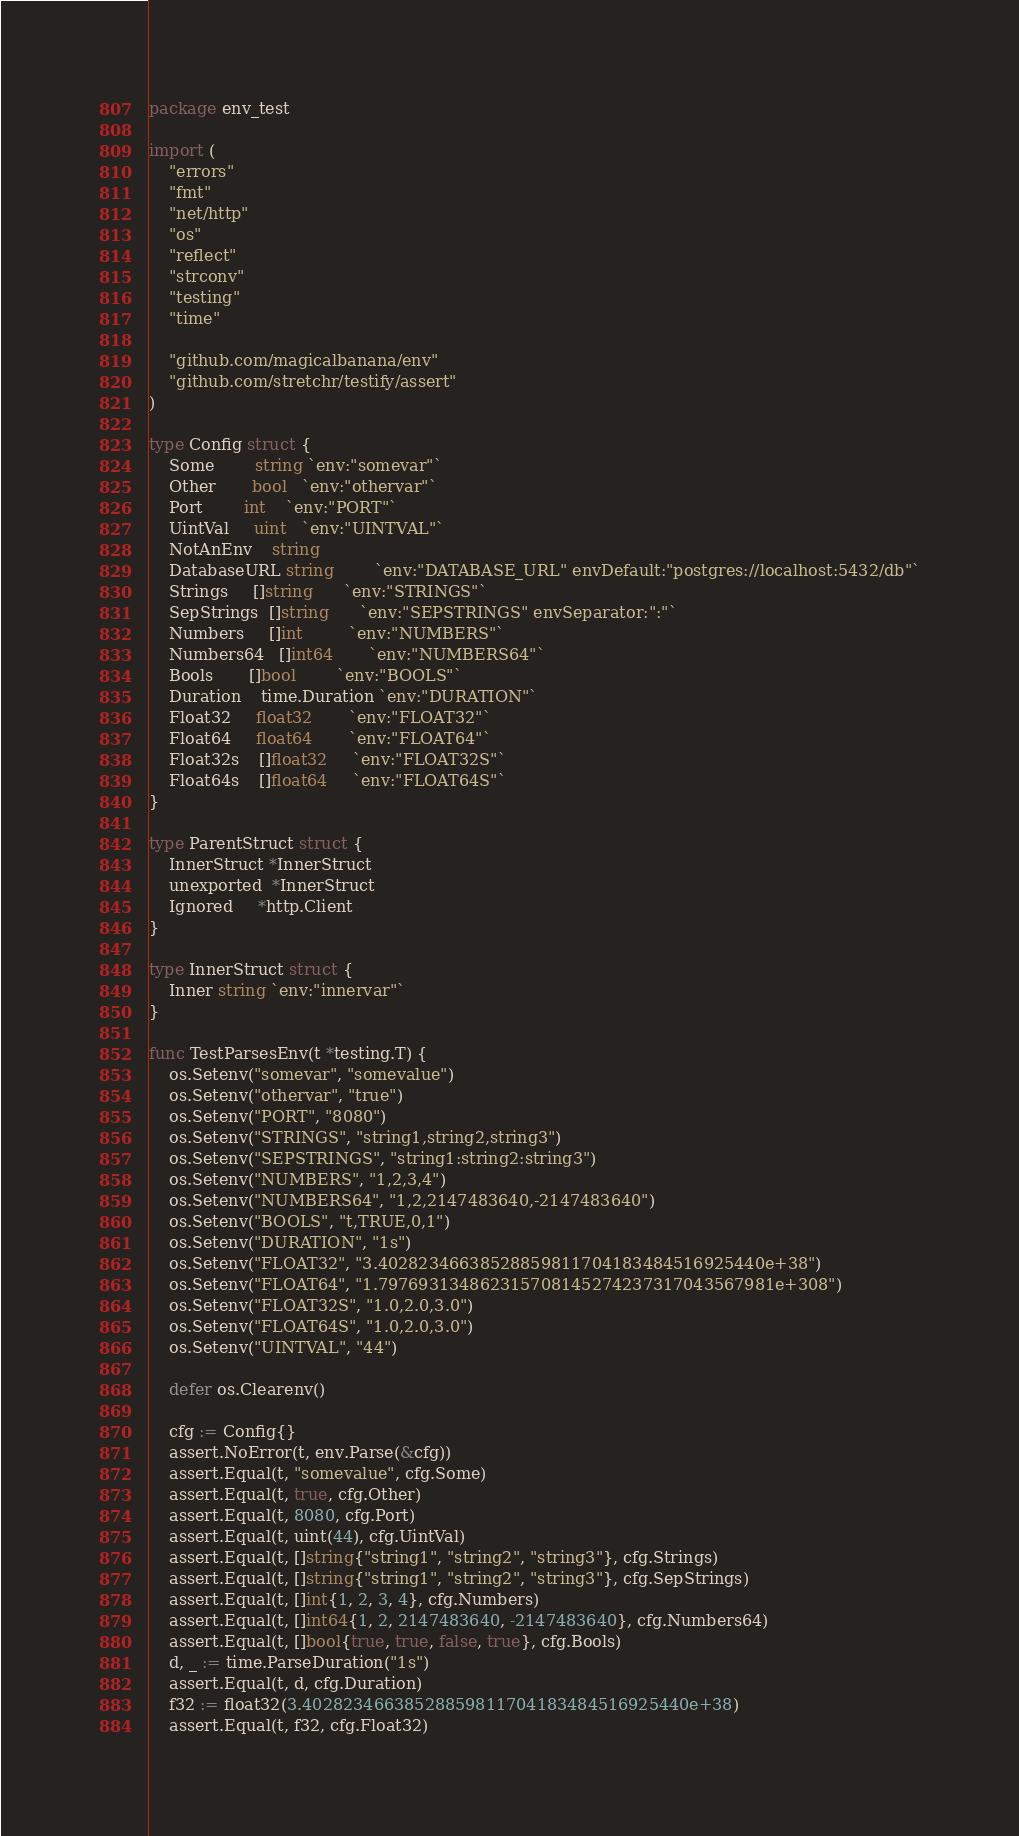<code> <loc_0><loc_0><loc_500><loc_500><_Go_>package env_test

import (
	"errors"
	"fmt"
	"net/http"
	"os"
	"reflect"
	"strconv"
	"testing"
	"time"

	"github.com/magicalbanana/env"
	"github.com/stretchr/testify/assert"
)

type Config struct {
	Some        string `env:"somevar"`
	Other       bool   `env:"othervar"`
	Port        int    `env:"PORT"`
	UintVal     uint   `env:"UINTVAL"`
	NotAnEnv    string
	DatabaseURL string        `env:"DATABASE_URL" envDefault:"postgres://localhost:5432/db"`
	Strings     []string      `env:"STRINGS"`
	SepStrings  []string      `env:"SEPSTRINGS" envSeparator:":"`
	Numbers     []int         `env:"NUMBERS"`
	Numbers64   []int64       `env:"NUMBERS64"`
	Bools       []bool        `env:"BOOLS"`
	Duration    time.Duration `env:"DURATION"`
	Float32     float32       `env:"FLOAT32"`
	Float64     float64       `env:"FLOAT64"`
	Float32s    []float32     `env:"FLOAT32S"`
	Float64s    []float64     `env:"FLOAT64S"`
}

type ParentStruct struct {
	InnerStruct *InnerStruct
	unexported  *InnerStruct
	Ignored     *http.Client
}

type InnerStruct struct {
	Inner string `env:"innervar"`
}

func TestParsesEnv(t *testing.T) {
	os.Setenv("somevar", "somevalue")
	os.Setenv("othervar", "true")
	os.Setenv("PORT", "8080")
	os.Setenv("STRINGS", "string1,string2,string3")
	os.Setenv("SEPSTRINGS", "string1:string2:string3")
	os.Setenv("NUMBERS", "1,2,3,4")
	os.Setenv("NUMBERS64", "1,2,2147483640,-2147483640")
	os.Setenv("BOOLS", "t,TRUE,0,1")
	os.Setenv("DURATION", "1s")
	os.Setenv("FLOAT32", "3.40282346638528859811704183484516925440e+38")
	os.Setenv("FLOAT64", "1.797693134862315708145274237317043567981e+308")
	os.Setenv("FLOAT32S", "1.0,2.0,3.0")
	os.Setenv("FLOAT64S", "1.0,2.0,3.0")
	os.Setenv("UINTVAL", "44")

	defer os.Clearenv()

	cfg := Config{}
	assert.NoError(t, env.Parse(&cfg))
	assert.Equal(t, "somevalue", cfg.Some)
	assert.Equal(t, true, cfg.Other)
	assert.Equal(t, 8080, cfg.Port)
	assert.Equal(t, uint(44), cfg.UintVal)
	assert.Equal(t, []string{"string1", "string2", "string3"}, cfg.Strings)
	assert.Equal(t, []string{"string1", "string2", "string3"}, cfg.SepStrings)
	assert.Equal(t, []int{1, 2, 3, 4}, cfg.Numbers)
	assert.Equal(t, []int64{1, 2, 2147483640, -2147483640}, cfg.Numbers64)
	assert.Equal(t, []bool{true, true, false, true}, cfg.Bools)
	d, _ := time.ParseDuration("1s")
	assert.Equal(t, d, cfg.Duration)
	f32 := float32(3.40282346638528859811704183484516925440e+38)
	assert.Equal(t, f32, cfg.Float32)</code> 